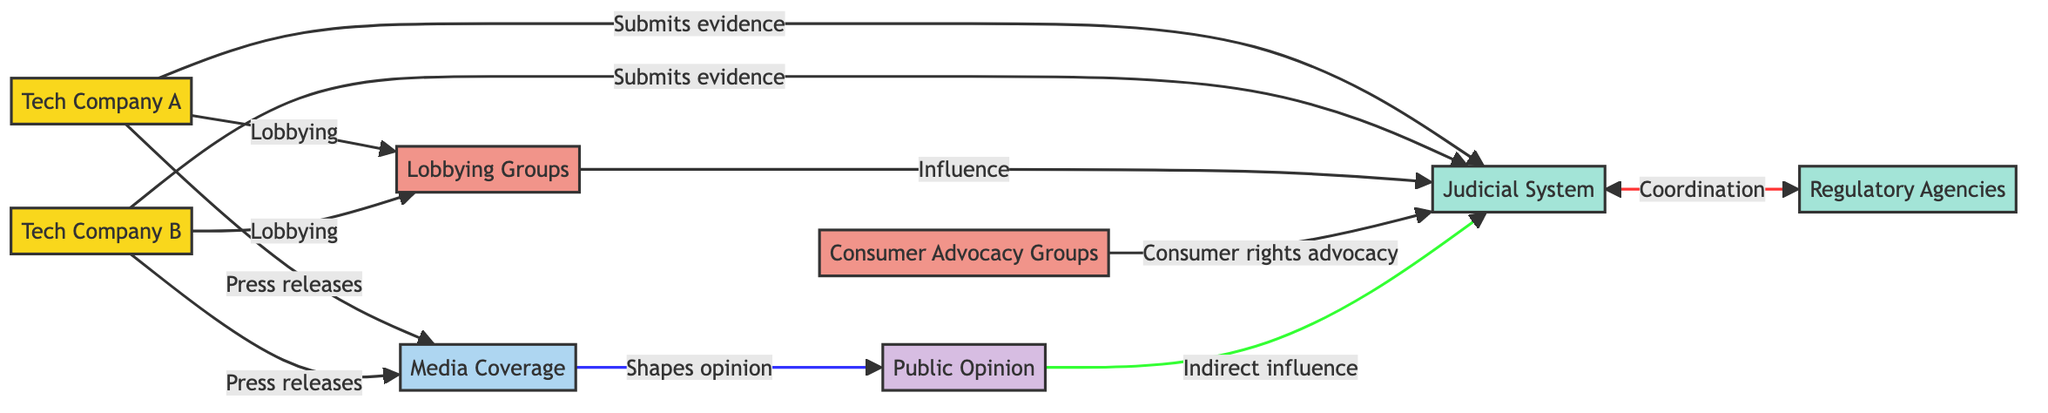What are the two tech companies involved in the legal dispute? The diagram shows "Tech Company A" and "Tech Company B" as two distinct nodes, signifying their involvement in the dispute.
Answer: Tech Company A, Tech Company B How many nodes are there in the diagram? The diagram lists eight nodes: Tech Company A, Tech Company B, Judicial System, Regulatory Agencies, Lobbying Groups, Consumer Advocacy Groups, Media Coverage, and Public Opinion. Counting these gives a total of eight nodes.
Answer: 8 What type of influence do Lobbying Groups have on the Judicial System? The diagram indicates that Lobbying Groups "Influence" the Judicial System, as shown by the directed edge connecting these two nodes.
Answer: Influence Which group is responsible for "Consumer rights advocacy"? The directed edge connects "Consumer Advocacy Groups" to the Judicial System, indicating that this group is responsible for advocating for consumer rights in the context of the legal battle.
Answer: Consumer Advocacy Groups What connects the Judicial System to Regulatory Agencies? The edges in the diagram indicate that there is "Coordination" between the Judicial System and Regulatory Agencies, pointing to a collaborative relationship between these nodes.
Answer: Coordination How do Media Coverage and Public Opinion interact in the diagram? The diagram demonstrates that "Media Coverage" shapes "Public Opinion," indicating a directional influence where media coverage impacts how the public perceives the situation.
Answer: Shapes opinion What is the relationship between Tech Company A and Lobbying Groups? Tech Company A has a directed edge pointing to Lobbying Groups labeled "Lobbying," indicating that Tech Company A engages in lobbying activities to influence these groups.
Answer: Lobbying How does Public Opinion exert influence on the Judicial System? The edge from Public Opinion to the Judicial System is labeled "Indirect influence," indicating that public sentiment can impact judicial proceedings subtly rather than directly.
Answer: Indirect influence How many edges are there in the diagram? By examining the connections, we can count a total of ten directed edges connecting the various nodes, demonstrating the relationships and influences among them.
Answer: 10 